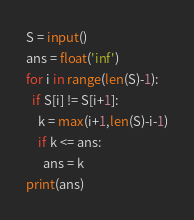<code> <loc_0><loc_0><loc_500><loc_500><_Python_>S = input()
ans = float('inf')
for i in range(len(S)-1):
  if S[i] != S[i+1]:
    k = max(i+1,len(S)-i-1)
    if k <= ans:
      ans = k
print(ans)</code> 